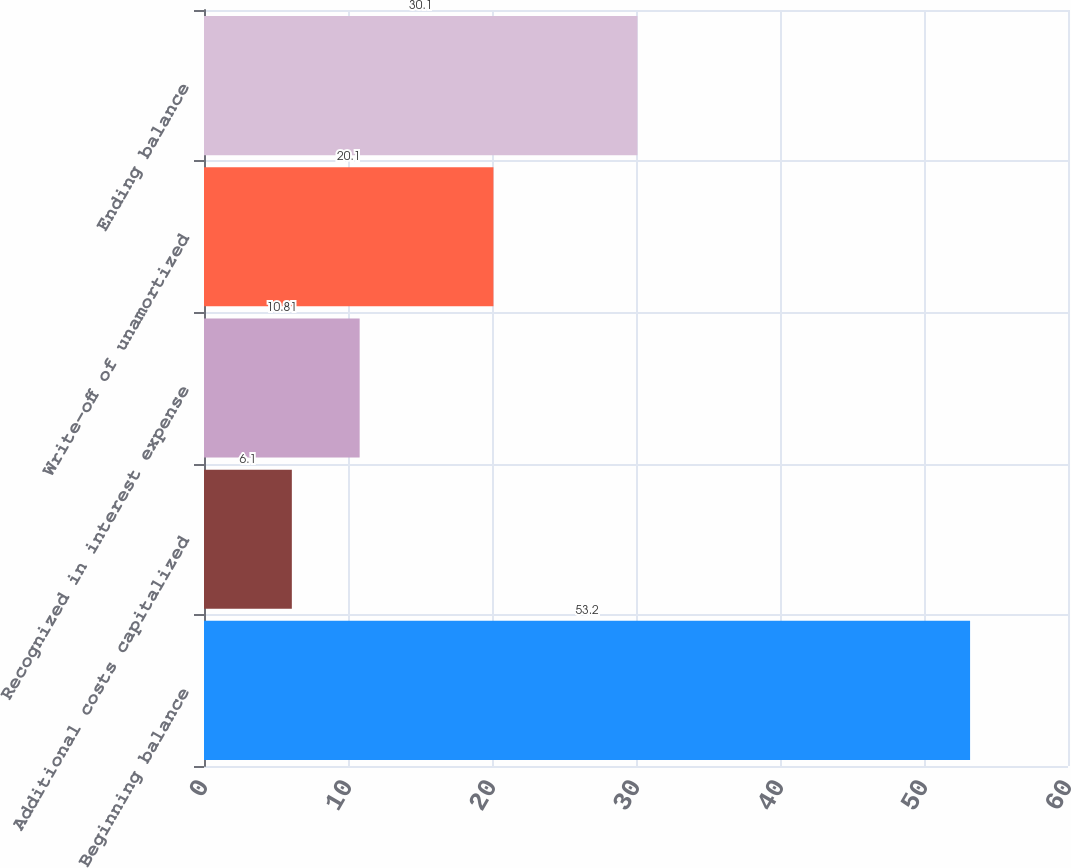Convert chart. <chart><loc_0><loc_0><loc_500><loc_500><bar_chart><fcel>Beginning balance<fcel>Additional costs capitalized<fcel>Recognized in interest expense<fcel>Write-off of unamortized<fcel>Ending balance<nl><fcel>53.2<fcel>6.1<fcel>10.81<fcel>20.1<fcel>30.1<nl></chart> 